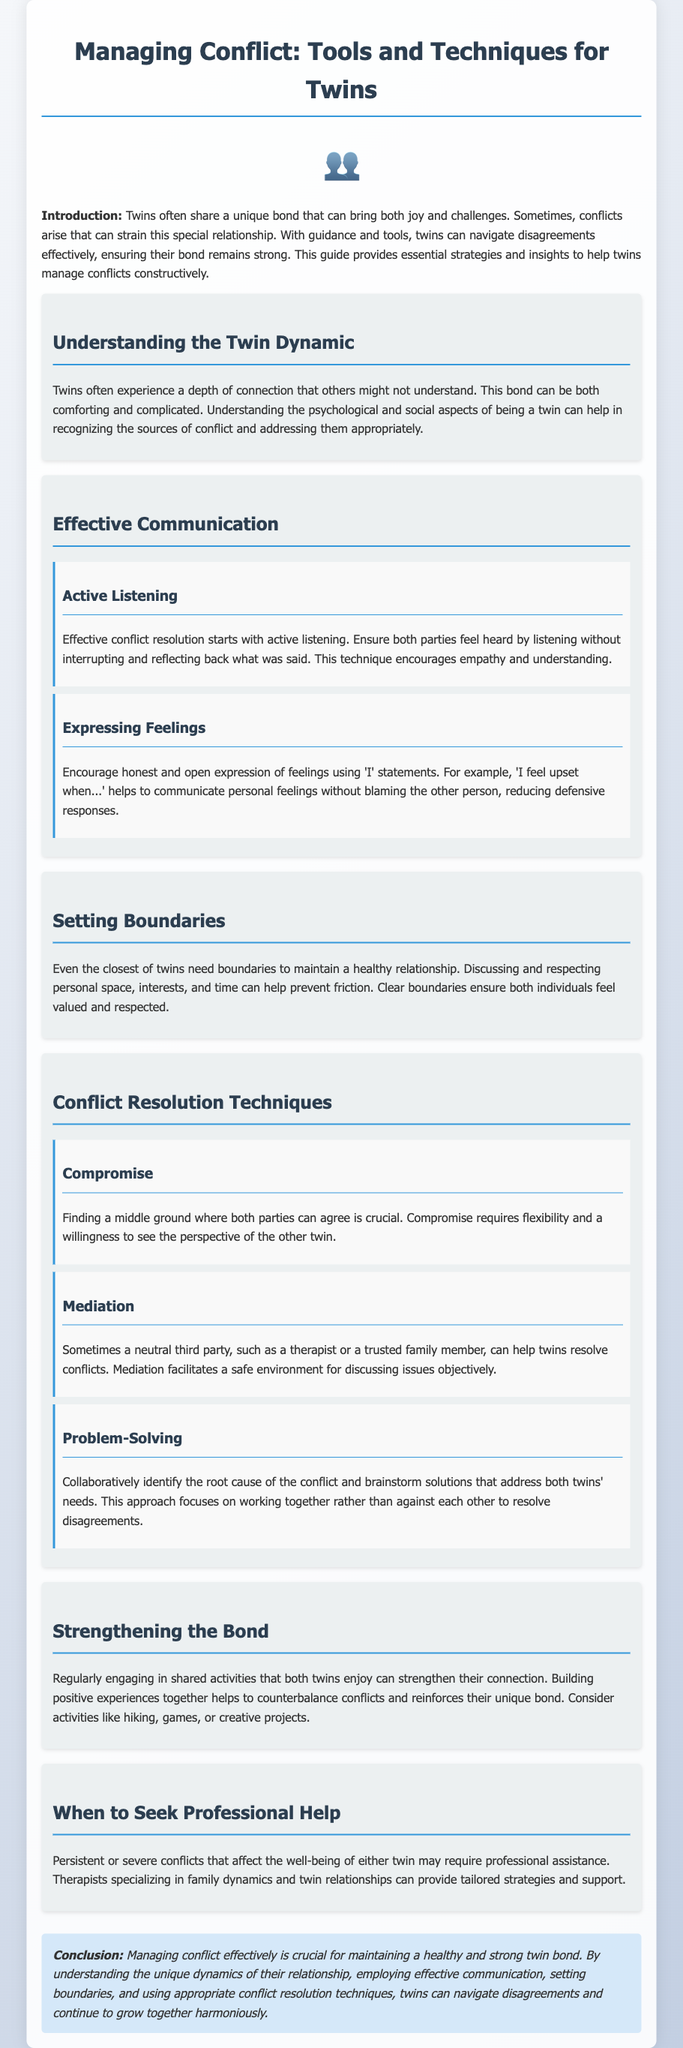what is the title of the document? The title of the document is specified in the header section, which outlines the main topic covered.
Answer: Managing Conflict: Tools and Techniques for Twins how many main sections are there in the document? Counting the main sections presented in the document provides the number of distinct topics covered.
Answer: 6 what is the first technique listed under Conflict Resolution Techniques? The document contains a section specifically addressing techniques for resolving conflicts, and lists them in a particular order.
Answer: Compromise what is emphasized as a crucial aspect of conflict resolution? The guide details various important elements that contribute to effective conflict resolution, highlighting one particular focus area.
Answer: Active Listening what should twins do when conflicts are severe? The document advises on actions twins should take if conflicts escalate beyond manageable levels, indicating professional intervention options.
Answer: Seek Professional Help how can twins strengthen their bond according to the guide? The guide includes recommendations for activities that help reinforce twin relationships and mitigate conflict effects.
Answer: Shared activities what type of statements should twins use to express feelings? The document highlights a specific communication style that encourages healthy emotional expression without blame during conflicts.
Answer: 'I' statements who can facilitate mediation according to the document? The section on mediation discusses the role of a neutral party, specifying potential candidates for this kind of intervention in conflicts.
Answer: Therapist or trusted family member 